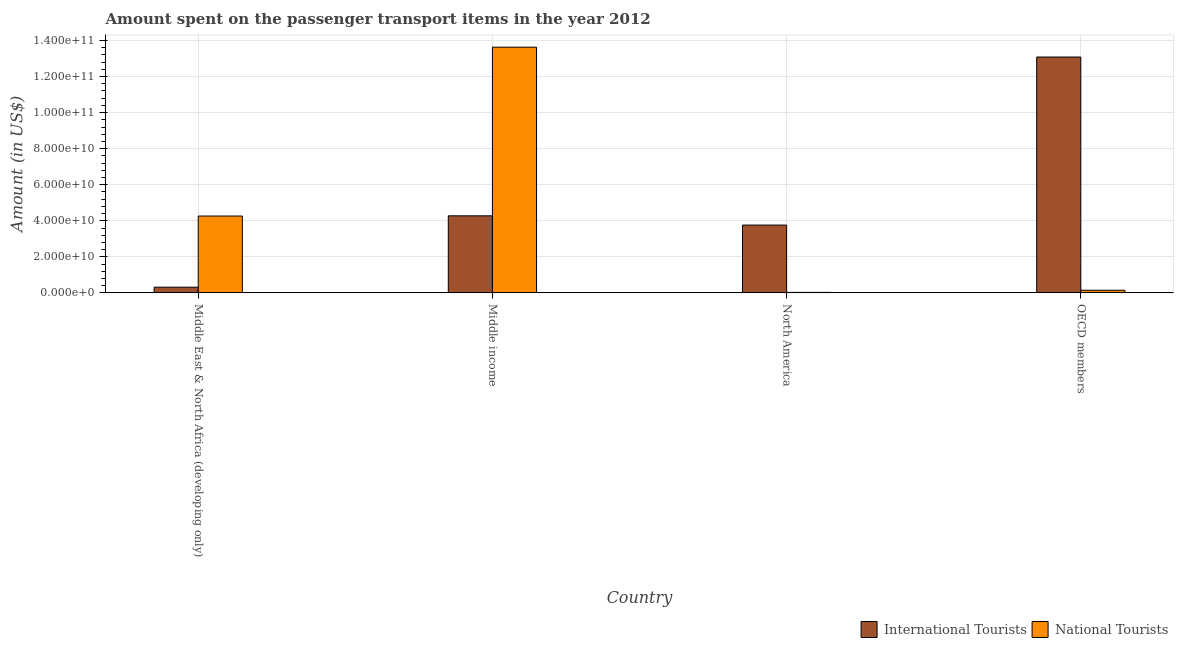How many different coloured bars are there?
Provide a succinct answer. 2. Are the number of bars per tick equal to the number of legend labels?
Provide a short and direct response. Yes. Are the number of bars on each tick of the X-axis equal?
Give a very brief answer. Yes. How many bars are there on the 2nd tick from the right?
Give a very brief answer. 2. In how many cases, is the number of bars for a given country not equal to the number of legend labels?
Your response must be concise. 0. What is the amount spent on transport items of international tourists in Middle income?
Ensure brevity in your answer.  4.28e+1. Across all countries, what is the maximum amount spent on transport items of national tourists?
Provide a succinct answer. 1.36e+11. Across all countries, what is the minimum amount spent on transport items of national tourists?
Your answer should be very brief. 3.10e+08. In which country was the amount spent on transport items of international tourists maximum?
Your answer should be very brief. OECD members. In which country was the amount spent on transport items of international tourists minimum?
Offer a very short reply. Middle East & North Africa (developing only). What is the total amount spent on transport items of national tourists in the graph?
Your answer should be compact. 1.81e+11. What is the difference between the amount spent on transport items of international tourists in Middle income and that in North America?
Your answer should be very brief. 5.13e+09. What is the difference between the amount spent on transport items of international tourists in Middle East & North Africa (developing only) and the amount spent on transport items of national tourists in North America?
Offer a terse response. 2.88e+09. What is the average amount spent on transport items of international tourists per country?
Offer a very short reply. 5.36e+1. What is the difference between the amount spent on transport items of international tourists and amount spent on transport items of national tourists in North America?
Your answer should be compact. 3.73e+1. What is the ratio of the amount spent on transport items of national tourists in Middle income to that in North America?
Ensure brevity in your answer.  439.15. Is the amount spent on transport items of national tourists in Middle income less than that in North America?
Ensure brevity in your answer.  No. What is the difference between the highest and the second highest amount spent on transport items of national tourists?
Offer a terse response. 9.37e+1. What is the difference between the highest and the lowest amount spent on transport items of national tourists?
Give a very brief answer. 1.36e+11. In how many countries, is the amount spent on transport items of national tourists greater than the average amount spent on transport items of national tourists taken over all countries?
Provide a succinct answer. 1. Is the sum of the amount spent on transport items of international tourists in Middle income and North America greater than the maximum amount spent on transport items of national tourists across all countries?
Offer a terse response. No. What does the 2nd bar from the left in North America represents?
Ensure brevity in your answer.  National Tourists. What does the 2nd bar from the right in Middle income represents?
Provide a short and direct response. International Tourists. How many bars are there?
Make the answer very short. 8. Are all the bars in the graph horizontal?
Your answer should be compact. No. How many countries are there in the graph?
Offer a terse response. 4. Does the graph contain grids?
Ensure brevity in your answer.  Yes. How many legend labels are there?
Your answer should be very brief. 2. What is the title of the graph?
Give a very brief answer. Amount spent on the passenger transport items in the year 2012. Does "Net savings(excluding particulate emission damage)" appear as one of the legend labels in the graph?
Offer a terse response. No. What is the Amount (in US$) in International Tourists in Middle East & North Africa (developing only)?
Give a very brief answer. 3.19e+09. What is the Amount (in US$) in National Tourists in Middle East & North Africa (developing only)?
Provide a succinct answer. 4.27e+1. What is the Amount (in US$) of International Tourists in Middle income?
Offer a very short reply. 4.28e+1. What is the Amount (in US$) of National Tourists in Middle income?
Offer a very short reply. 1.36e+11. What is the Amount (in US$) in International Tourists in North America?
Keep it short and to the point. 3.76e+1. What is the Amount (in US$) of National Tourists in North America?
Give a very brief answer. 3.10e+08. What is the Amount (in US$) of International Tourists in OECD members?
Give a very brief answer. 1.31e+11. What is the Amount (in US$) in National Tourists in OECD members?
Offer a terse response. 1.49e+09. Across all countries, what is the maximum Amount (in US$) in International Tourists?
Provide a short and direct response. 1.31e+11. Across all countries, what is the maximum Amount (in US$) of National Tourists?
Ensure brevity in your answer.  1.36e+11. Across all countries, what is the minimum Amount (in US$) of International Tourists?
Your answer should be compact. 3.19e+09. Across all countries, what is the minimum Amount (in US$) of National Tourists?
Give a very brief answer. 3.10e+08. What is the total Amount (in US$) in International Tourists in the graph?
Your answer should be very brief. 2.14e+11. What is the total Amount (in US$) in National Tourists in the graph?
Your answer should be very brief. 1.81e+11. What is the difference between the Amount (in US$) of International Tourists in Middle East & North Africa (developing only) and that in Middle income?
Offer a very short reply. -3.96e+1. What is the difference between the Amount (in US$) of National Tourists in Middle East & North Africa (developing only) and that in Middle income?
Make the answer very short. -9.37e+1. What is the difference between the Amount (in US$) of International Tourists in Middle East & North Africa (developing only) and that in North America?
Give a very brief answer. -3.45e+1. What is the difference between the Amount (in US$) of National Tourists in Middle East & North Africa (developing only) and that in North America?
Give a very brief answer. 4.23e+1. What is the difference between the Amount (in US$) in International Tourists in Middle East & North Africa (developing only) and that in OECD members?
Your answer should be very brief. -1.28e+11. What is the difference between the Amount (in US$) of National Tourists in Middle East & North Africa (developing only) and that in OECD members?
Your answer should be compact. 4.12e+1. What is the difference between the Amount (in US$) in International Tourists in Middle income and that in North America?
Offer a very short reply. 5.13e+09. What is the difference between the Amount (in US$) of National Tourists in Middle income and that in North America?
Provide a succinct answer. 1.36e+11. What is the difference between the Amount (in US$) in International Tourists in Middle income and that in OECD members?
Ensure brevity in your answer.  -8.81e+1. What is the difference between the Amount (in US$) in National Tourists in Middle income and that in OECD members?
Your response must be concise. 1.35e+11. What is the difference between the Amount (in US$) in International Tourists in North America and that in OECD members?
Offer a terse response. -9.32e+1. What is the difference between the Amount (in US$) in National Tourists in North America and that in OECD members?
Make the answer very short. -1.18e+09. What is the difference between the Amount (in US$) of International Tourists in Middle East & North Africa (developing only) and the Amount (in US$) of National Tourists in Middle income?
Offer a very short reply. -1.33e+11. What is the difference between the Amount (in US$) of International Tourists in Middle East & North Africa (developing only) and the Amount (in US$) of National Tourists in North America?
Provide a short and direct response. 2.88e+09. What is the difference between the Amount (in US$) of International Tourists in Middle East & North Africa (developing only) and the Amount (in US$) of National Tourists in OECD members?
Give a very brief answer. 1.70e+09. What is the difference between the Amount (in US$) of International Tourists in Middle income and the Amount (in US$) of National Tourists in North America?
Keep it short and to the point. 4.25e+1. What is the difference between the Amount (in US$) in International Tourists in Middle income and the Amount (in US$) in National Tourists in OECD members?
Ensure brevity in your answer.  4.13e+1. What is the difference between the Amount (in US$) of International Tourists in North America and the Amount (in US$) of National Tourists in OECD members?
Your answer should be compact. 3.62e+1. What is the average Amount (in US$) of International Tourists per country?
Offer a terse response. 5.36e+1. What is the average Amount (in US$) in National Tourists per country?
Your answer should be very brief. 4.52e+1. What is the difference between the Amount (in US$) in International Tourists and Amount (in US$) in National Tourists in Middle East & North Africa (developing only)?
Provide a short and direct response. -3.95e+1. What is the difference between the Amount (in US$) of International Tourists and Amount (in US$) of National Tourists in Middle income?
Offer a very short reply. -9.35e+1. What is the difference between the Amount (in US$) in International Tourists and Amount (in US$) in National Tourists in North America?
Ensure brevity in your answer.  3.73e+1. What is the difference between the Amount (in US$) of International Tourists and Amount (in US$) of National Tourists in OECD members?
Provide a short and direct response. 1.29e+11. What is the ratio of the Amount (in US$) in International Tourists in Middle East & North Africa (developing only) to that in Middle income?
Offer a terse response. 0.07. What is the ratio of the Amount (in US$) of National Tourists in Middle East & North Africa (developing only) to that in Middle income?
Ensure brevity in your answer.  0.31. What is the ratio of the Amount (in US$) of International Tourists in Middle East & North Africa (developing only) to that in North America?
Your answer should be very brief. 0.08. What is the ratio of the Amount (in US$) in National Tourists in Middle East & North Africa (developing only) to that in North America?
Your response must be concise. 137.42. What is the ratio of the Amount (in US$) in International Tourists in Middle East & North Africa (developing only) to that in OECD members?
Ensure brevity in your answer.  0.02. What is the ratio of the Amount (in US$) in National Tourists in Middle East & North Africa (developing only) to that in OECD members?
Make the answer very short. 28.68. What is the ratio of the Amount (in US$) in International Tourists in Middle income to that in North America?
Offer a very short reply. 1.14. What is the ratio of the Amount (in US$) of National Tourists in Middle income to that in North America?
Your answer should be compact. 439.15. What is the ratio of the Amount (in US$) of International Tourists in Middle income to that in OECD members?
Keep it short and to the point. 0.33. What is the ratio of the Amount (in US$) in National Tourists in Middle income to that in OECD members?
Provide a short and direct response. 91.66. What is the ratio of the Amount (in US$) of International Tourists in North America to that in OECD members?
Give a very brief answer. 0.29. What is the ratio of the Amount (in US$) of National Tourists in North America to that in OECD members?
Your answer should be very brief. 0.21. What is the difference between the highest and the second highest Amount (in US$) in International Tourists?
Provide a succinct answer. 8.81e+1. What is the difference between the highest and the second highest Amount (in US$) of National Tourists?
Your answer should be compact. 9.37e+1. What is the difference between the highest and the lowest Amount (in US$) in International Tourists?
Make the answer very short. 1.28e+11. What is the difference between the highest and the lowest Amount (in US$) of National Tourists?
Your answer should be compact. 1.36e+11. 